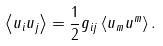<formula> <loc_0><loc_0><loc_500><loc_500>\left \langle u _ { i } u _ { j } \right \rangle = \frac { 1 } { 2 } g _ { i j } \left \langle u _ { m } u ^ { m } \right \rangle .</formula> 